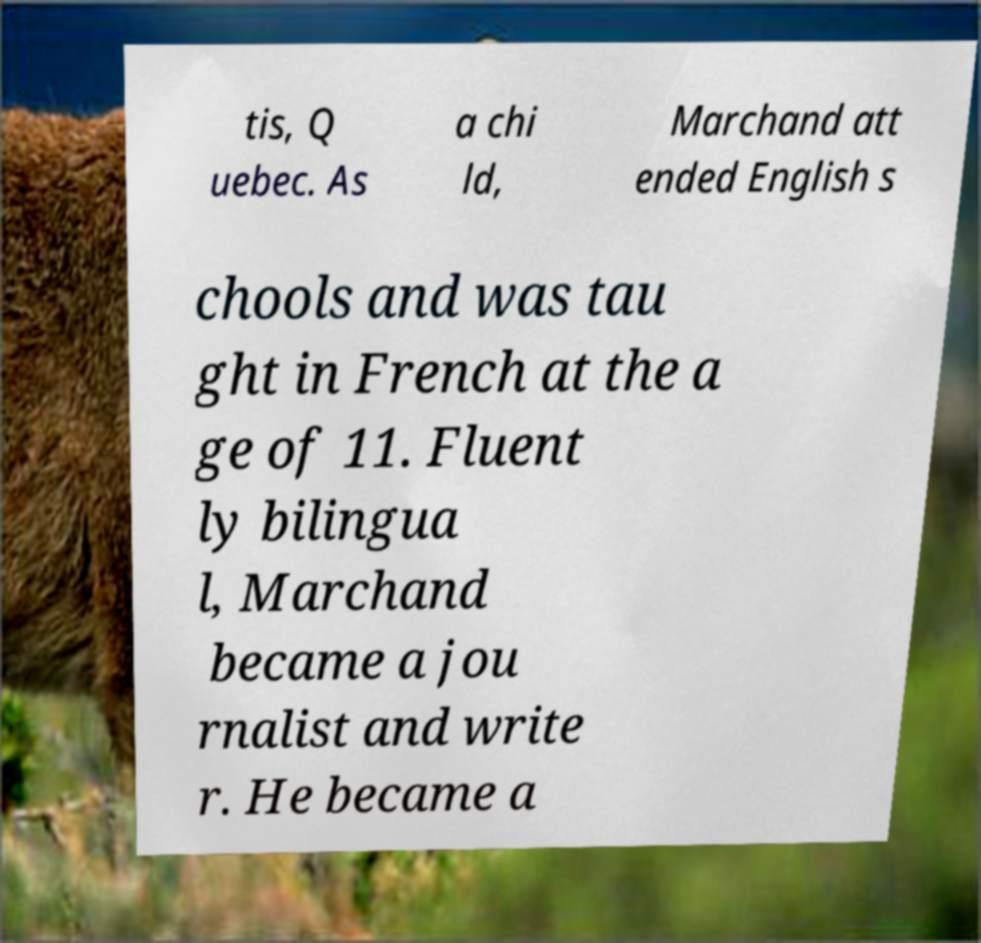For documentation purposes, I need the text within this image transcribed. Could you provide that? tis, Q uebec. As a chi ld, Marchand att ended English s chools and was tau ght in French at the a ge of 11. Fluent ly bilingua l, Marchand became a jou rnalist and write r. He became a 